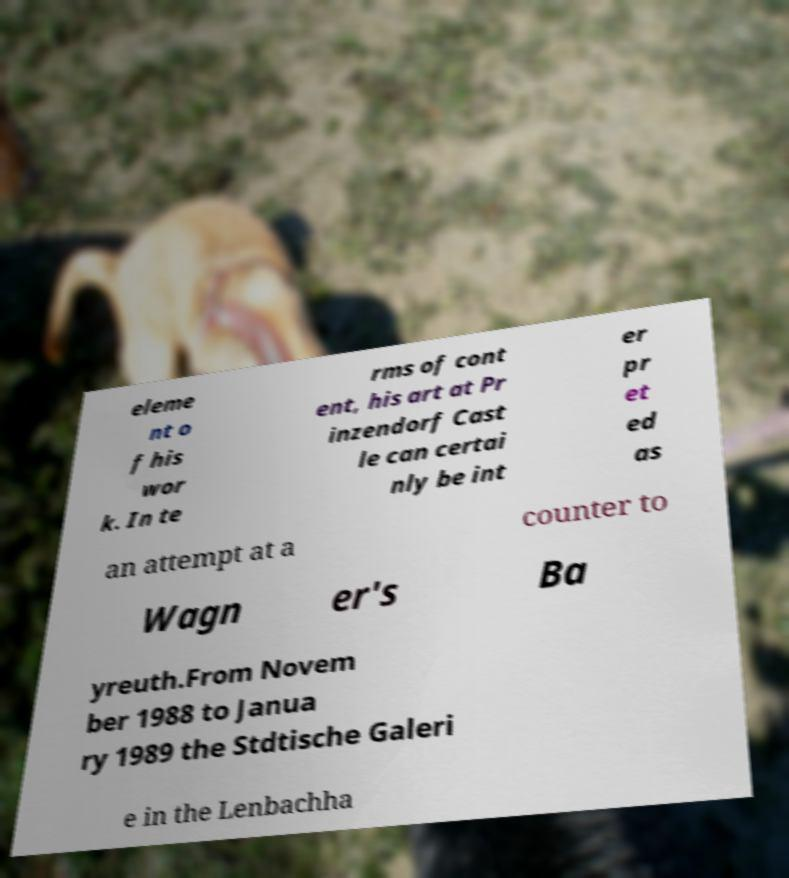For documentation purposes, I need the text within this image transcribed. Could you provide that? eleme nt o f his wor k. In te rms of cont ent, his art at Pr inzendorf Cast le can certai nly be int er pr et ed as an attempt at a counter to Wagn er's Ba yreuth.From Novem ber 1988 to Janua ry 1989 the Stdtische Galeri e in the Lenbachha 